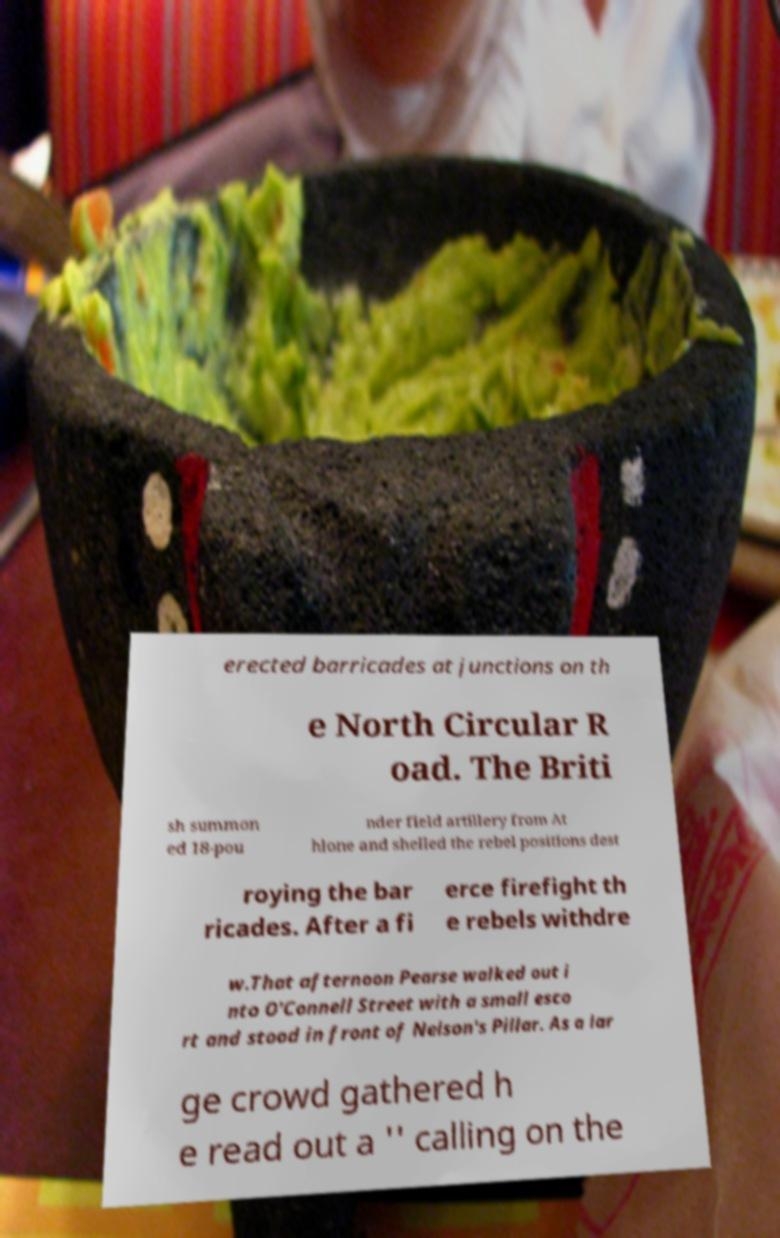For documentation purposes, I need the text within this image transcribed. Could you provide that? erected barricades at junctions on th e North Circular R oad. The Briti sh summon ed 18-pou nder field artillery from At hlone and shelled the rebel positions dest roying the bar ricades. After a fi erce firefight th e rebels withdre w.That afternoon Pearse walked out i nto O'Connell Street with a small esco rt and stood in front of Nelson's Pillar. As a lar ge crowd gathered h e read out a '' calling on the 